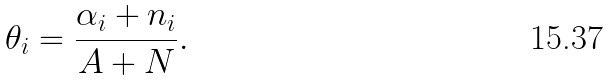Convert formula to latex. <formula><loc_0><loc_0><loc_500><loc_500>\theta _ { i } = \frac { \alpha _ { i } + n _ { i } } { A + N } .</formula> 